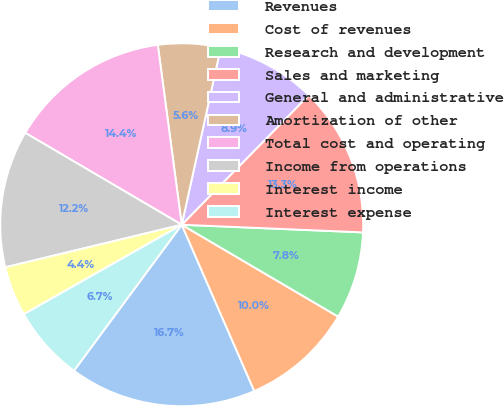<chart> <loc_0><loc_0><loc_500><loc_500><pie_chart><fcel>Revenues<fcel>Cost of revenues<fcel>Research and development<fcel>Sales and marketing<fcel>General and administrative<fcel>Amortization of other<fcel>Total cost and operating<fcel>Income from operations<fcel>Interest income<fcel>Interest expense<nl><fcel>16.67%<fcel>10.0%<fcel>7.78%<fcel>13.33%<fcel>8.89%<fcel>5.56%<fcel>14.44%<fcel>12.22%<fcel>4.44%<fcel>6.67%<nl></chart> 